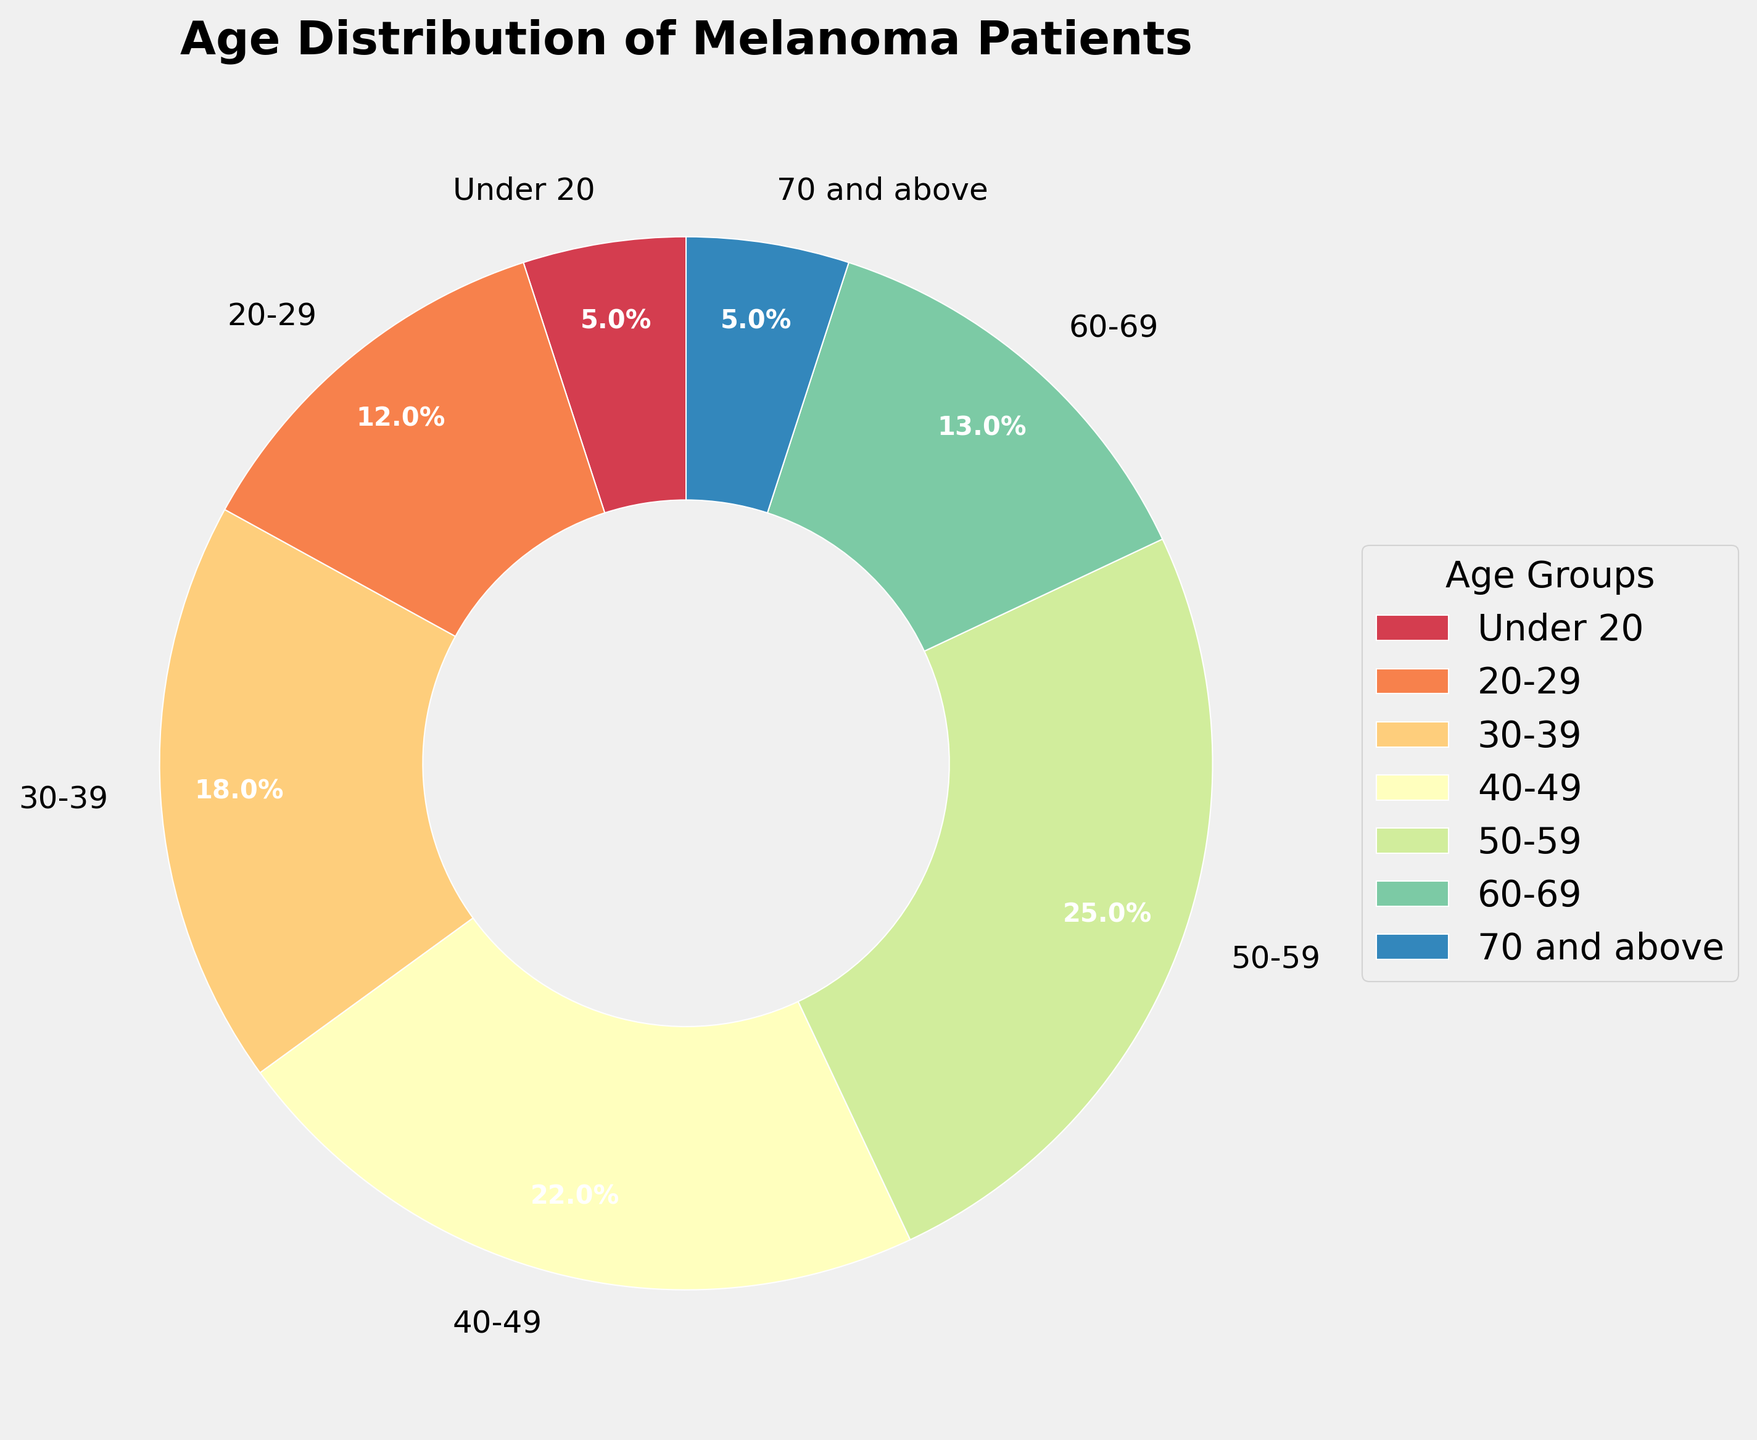What's the age group with the highest percentage of melanoma patients? The chart shows different age groups with their corresponding percentages. The age group with the highest percentage is the 50-59 group, labeled with 25%.
Answer: 50-59 Compare the percentage of melanoma patients in the age groups 40-49 and 60-69. Which group has a higher percentage? By observing the chart, the 40-49 age group has 22%, whereas the 60-69 age group has 13%. Hence, the 40-49 group has a higher percentage.
Answer: 40-49 What is the combined percentage of melanoma patients under 30 years old? The under 20 age group has 5%, and the 20-29 age group has 12%. Adding these percentages gives 5% + 12% = 17%.
Answer: 17% How does the percentage of melanoma patients aged 70 and above compare to those aged 60-69? The chart shows that both the 70 and above group and the under 20 group have 5%, while the 60-69 group has 13%. Therefore, the 70 and above group has a lower percentage than the 60-69 group.
Answer: Lower Which age group has the smallest wedge in the pie chart? The smallest wedge in the pie chart corresponds to the smallest percentage, which is 5%. Both the under 20 and the 70 and above age groups have this percentage.
Answer: Under 20 and 70 and above If the total number of melanoma patients is 200, how many patients are in the 30-39 age group? The 30-39 age group comprises 18% of the total. To find the number of patients, calculate 18% of 200: (200 * 18) / 100 = 36 patients.
Answer: 36 Compare the percentages of melanoma patients aged 50-59 to all other age groups combined. Is their percentage higher or lower? The 50-59 age group has 25%. Adding the percentages of all other groups: 5 + 12 + 18 + 22 + 13 + 5 = 75%. Therefore, the 50-59 age group has a lower percentage.
Answer: Lower What's the percentage difference between the age groups with the second-highest and the lowest melanoma patient percentage? The second-highest percentage is the 40-49 age group with 22%, and the lowest percentages are under 20 and 70 and above, both at 5%. The difference is 22% - 5% = 17%.
Answer: 17% What is the combined percentage of patients in the age groups 40-49 and 50-59? The 40-49 group has 22%, and the 50-59 group has 25%. Summing these gives 22% + 25% = 47%.
Answer: 47% Identify the age group that occupies the second-smallest wedge in the pie chart. By examining the chart, the second-smallest wedge corresponds to the 20-29 group with 12%, as only the under 20 and 70 and above have smaller wedges with 5% each.
Answer: 20-29 